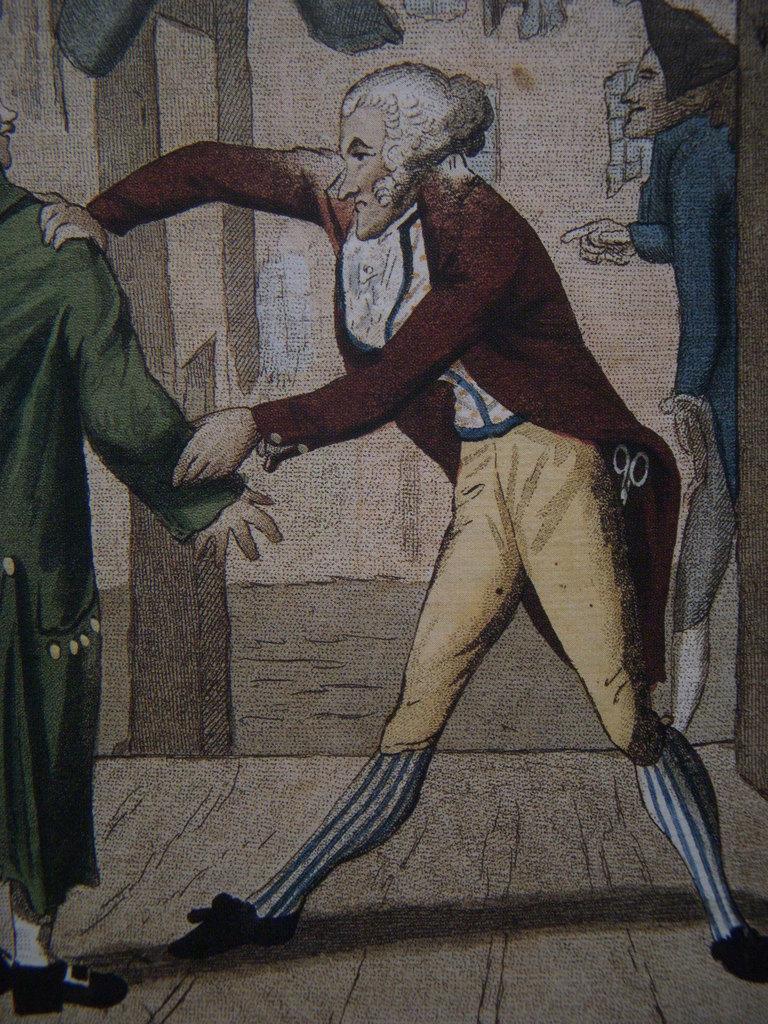In one or two sentences, can you explain what this image depicts? This is a picture of a painting, in this image we can see the persons standing on the floor, in the background, we can see the wall, windows and a pillar. 